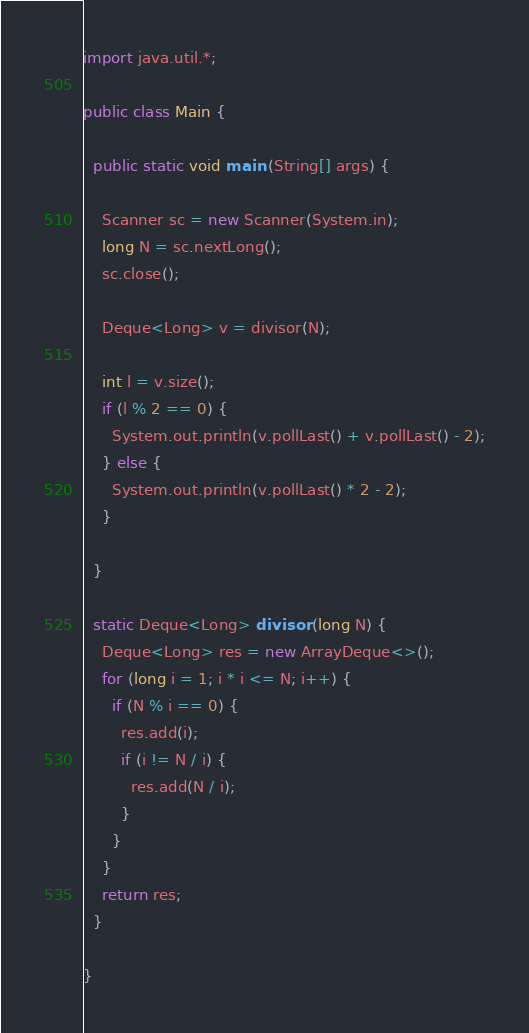Convert code to text. <code><loc_0><loc_0><loc_500><loc_500><_Java_>import java.util.*;

public class Main {

  public static void main (String[] args) {

    Scanner sc = new Scanner(System.in);
    long N = sc.nextLong();
    sc.close();

    Deque<Long> v = divisor(N);

    int l = v.size();
    if (l % 2 == 0) {
      System.out.println(v.pollLast() + v.pollLast() - 2);
    } else {
      System.out.println(v.pollLast() * 2 - 2);
    }

  }

  static Deque<Long> divisor (long N) {
    Deque<Long> res = new ArrayDeque<>();
    for (long i = 1; i * i <= N; i++) {
      if (N % i == 0) {
        res.add(i);
        if (i != N / i) {
          res.add(N / i);
        }
      }
    }
    return res;
  }

}</code> 